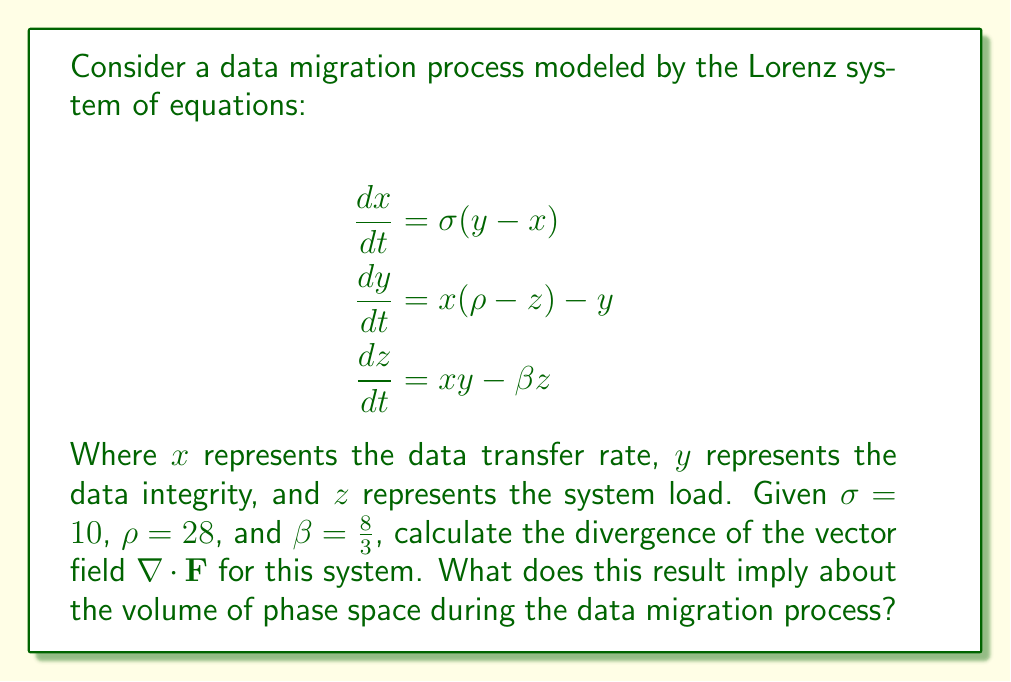Could you help me with this problem? To solve this problem, we'll follow these steps:

1) The vector field $\mathbf{F}$ for the Lorenz system is:

   $$\mathbf{F} = (\sigma(y - x), x(\rho - z) - y, xy - \beta z)$$

2) The divergence of a vector field in 3D is given by:

   $$\nabla \cdot \mathbf{F} = \frac{\partial F_x}{\partial x} + \frac{\partial F_y}{\partial y} + \frac{\partial F_z}{\partial z}$$

3) Let's calculate each partial derivative:

   $$\frac{\partial F_x}{\partial x} = -\sigma$$
   $$\frac{\partial F_y}{\partial y} = -1$$
   $$\frac{\partial F_z}{\partial z} = -\beta$$

4) Now, we can sum these to get the divergence:

   $$\nabla \cdot \mathbf{F} = -\sigma - 1 - \beta$$

5) Substituting the given values:

   $$\nabla \cdot \mathbf{F} = -10 - 1 - \frac{8}{3} = -\frac{41}{3}$$

6) The divergence is negative, which implies that the volume of phase space is contracting over time. In the context of data migration, this suggests that the system is converging towards a strange attractor, representing a stable state where the data transfer rate, data integrity, and system load are in a complex but controlled balance.
Answer: $-\frac{41}{3}$; Volume of phase space contracts, system converges to strange attractor. 